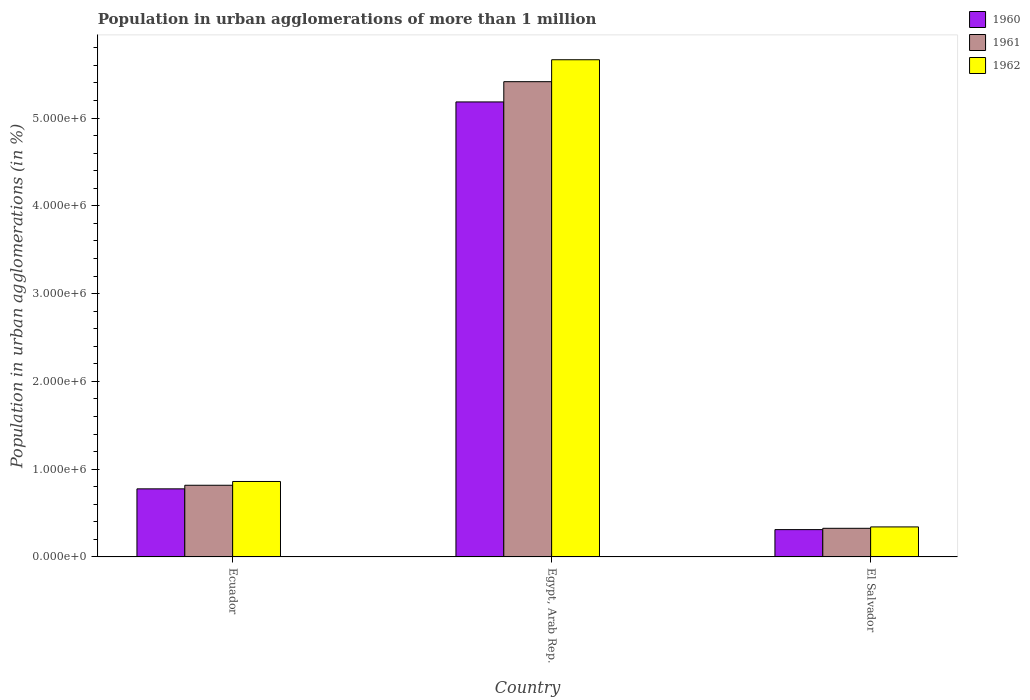How many groups of bars are there?
Keep it short and to the point. 3. Are the number of bars on each tick of the X-axis equal?
Offer a very short reply. Yes. How many bars are there on the 2nd tick from the left?
Offer a very short reply. 3. How many bars are there on the 3rd tick from the right?
Your answer should be very brief. 3. What is the label of the 2nd group of bars from the left?
Make the answer very short. Egypt, Arab Rep. What is the population in urban agglomerations in 1962 in Ecuador?
Your answer should be very brief. 8.60e+05. Across all countries, what is the maximum population in urban agglomerations in 1960?
Provide a succinct answer. 5.18e+06. Across all countries, what is the minimum population in urban agglomerations in 1962?
Provide a succinct answer. 3.42e+05. In which country was the population in urban agglomerations in 1960 maximum?
Offer a very short reply. Egypt, Arab Rep. In which country was the population in urban agglomerations in 1962 minimum?
Offer a terse response. El Salvador. What is the total population in urban agglomerations in 1962 in the graph?
Keep it short and to the point. 6.87e+06. What is the difference between the population in urban agglomerations in 1962 in Egypt, Arab Rep. and that in El Salvador?
Provide a succinct answer. 5.32e+06. What is the difference between the population in urban agglomerations in 1961 in Ecuador and the population in urban agglomerations in 1962 in Egypt, Arab Rep.?
Make the answer very short. -4.85e+06. What is the average population in urban agglomerations in 1962 per country?
Your response must be concise. 2.29e+06. What is the difference between the population in urban agglomerations of/in 1961 and population in urban agglomerations of/in 1960 in Egypt, Arab Rep.?
Give a very brief answer. 2.31e+05. In how many countries, is the population in urban agglomerations in 1961 greater than 3600000 %?
Your answer should be very brief. 1. What is the ratio of the population in urban agglomerations in 1962 in Ecuador to that in Egypt, Arab Rep.?
Provide a succinct answer. 0.15. What is the difference between the highest and the second highest population in urban agglomerations in 1962?
Provide a succinct answer. -5.32e+06. What is the difference between the highest and the lowest population in urban agglomerations in 1960?
Your response must be concise. 4.87e+06. What does the 3rd bar from the right in Egypt, Arab Rep. represents?
Provide a succinct answer. 1960. How many bars are there?
Your answer should be compact. 9. How many countries are there in the graph?
Your response must be concise. 3. What is the difference between two consecutive major ticks on the Y-axis?
Provide a succinct answer. 1.00e+06. Does the graph contain grids?
Offer a very short reply. No. Where does the legend appear in the graph?
Keep it short and to the point. Top right. How many legend labels are there?
Ensure brevity in your answer.  3. What is the title of the graph?
Your response must be concise. Population in urban agglomerations of more than 1 million. Does "1982" appear as one of the legend labels in the graph?
Your answer should be very brief. No. What is the label or title of the Y-axis?
Offer a terse response. Population in urban agglomerations (in %). What is the Population in urban agglomerations (in %) of 1960 in Ecuador?
Keep it short and to the point. 7.76e+05. What is the Population in urban agglomerations (in %) of 1961 in Ecuador?
Your response must be concise. 8.16e+05. What is the Population in urban agglomerations (in %) of 1962 in Ecuador?
Give a very brief answer. 8.60e+05. What is the Population in urban agglomerations (in %) in 1960 in Egypt, Arab Rep.?
Your answer should be compact. 5.18e+06. What is the Population in urban agglomerations (in %) in 1961 in Egypt, Arab Rep.?
Your answer should be compact. 5.41e+06. What is the Population in urban agglomerations (in %) of 1962 in Egypt, Arab Rep.?
Your answer should be very brief. 5.66e+06. What is the Population in urban agglomerations (in %) in 1960 in El Salvador?
Offer a very short reply. 3.11e+05. What is the Population in urban agglomerations (in %) in 1961 in El Salvador?
Offer a terse response. 3.26e+05. What is the Population in urban agglomerations (in %) of 1962 in El Salvador?
Your response must be concise. 3.42e+05. Across all countries, what is the maximum Population in urban agglomerations (in %) of 1960?
Ensure brevity in your answer.  5.18e+06. Across all countries, what is the maximum Population in urban agglomerations (in %) in 1961?
Keep it short and to the point. 5.41e+06. Across all countries, what is the maximum Population in urban agglomerations (in %) in 1962?
Keep it short and to the point. 5.66e+06. Across all countries, what is the minimum Population in urban agglomerations (in %) of 1960?
Your answer should be very brief. 3.11e+05. Across all countries, what is the minimum Population in urban agglomerations (in %) in 1961?
Your response must be concise. 3.26e+05. Across all countries, what is the minimum Population in urban agglomerations (in %) in 1962?
Offer a terse response. 3.42e+05. What is the total Population in urban agglomerations (in %) in 1960 in the graph?
Offer a very short reply. 6.27e+06. What is the total Population in urban agglomerations (in %) of 1961 in the graph?
Ensure brevity in your answer.  6.56e+06. What is the total Population in urban agglomerations (in %) in 1962 in the graph?
Your response must be concise. 6.87e+06. What is the difference between the Population in urban agglomerations (in %) in 1960 in Ecuador and that in Egypt, Arab Rep.?
Your answer should be very brief. -4.41e+06. What is the difference between the Population in urban agglomerations (in %) in 1961 in Ecuador and that in Egypt, Arab Rep.?
Ensure brevity in your answer.  -4.60e+06. What is the difference between the Population in urban agglomerations (in %) of 1962 in Ecuador and that in Egypt, Arab Rep.?
Give a very brief answer. -4.81e+06. What is the difference between the Population in urban agglomerations (in %) of 1960 in Ecuador and that in El Salvador?
Give a very brief answer. 4.64e+05. What is the difference between the Population in urban agglomerations (in %) in 1961 in Ecuador and that in El Salvador?
Offer a very short reply. 4.90e+05. What is the difference between the Population in urban agglomerations (in %) of 1962 in Ecuador and that in El Salvador?
Offer a very short reply. 5.18e+05. What is the difference between the Population in urban agglomerations (in %) of 1960 in Egypt, Arab Rep. and that in El Salvador?
Give a very brief answer. 4.87e+06. What is the difference between the Population in urban agglomerations (in %) in 1961 in Egypt, Arab Rep. and that in El Salvador?
Ensure brevity in your answer.  5.09e+06. What is the difference between the Population in urban agglomerations (in %) of 1962 in Egypt, Arab Rep. and that in El Salvador?
Provide a succinct answer. 5.32e+06. What is the difference between the Population in urban agglomerations (in %) of 1960 in Ecuador and the Population in urban agglomerations (in %) of 1961 in Egypt, Arab Rep.?
Provide a short and direct response. -4.64e+06. What is the difference between the Population in urban agglomerations (in %) in 1960 in Ecuador and the Population in urban agglomerations (in %) in 1962 in Egypt, Arab Rep.?
Your answer should be very brief. -4.89e+06. What is the difference between the Population in urban agglomerations (in %) of 1961 in Ecuador and the Population in urban agglomerations (in %) of 1962 in Egypt, Arab Rep.?
Offer a terse response. -4.85e+06. What is the difference between the Population in urban agglomerations (in %) of 1960 in Ecuador and the Population in urban agglomerations (in %) of 1961 in El Salvador?
Provide a short and direct response. 4.49e+05. What is the difference between the Population in urban agglomerations (in %) in 1960 in Ecuador and the Population in urban agglomerations (in %) in 1962 in El Salvador?
Give a very brief answer. 4.34e+05. What is the difference between the Population in urban agglomerations (in %) of 1961 in Ecuador and the Population in urban agglomerations (in %) of 1962 in El Salvador?
Your answer should be compact. 4.74e+05. What is the difference between the Population in urban agglomerations (in %) in 1960 in Egypt, Arab Rep. and the Population in urban agglomerations (in %) in 1961 in El Salvador?
Offer a terse response. 4.86e+06. What is the difference between the Population in urban agglomerations (in %) in 1960 in Egypt, Arab Rep. and the Population in urban agglomerations (in %) in 1962 in El Salvador?
Your answer should be compact. 4.84e+06. What is the difference between the Population in urban agglomerations (in %) in 1961 in Egypt, Arab Rep. and the Population in urban agglomerations (in %) in 1962 in El Salvador?
Your response must be concise. 5.07e+06. What is the average Population in urban agglomerations (in %) of 1960 per country?
Keep it short and to the point. 2.09e+06. What is the average Population in urban agglomerations (in %) of 1961 per country?
Keep it short and to the point. 2.19e+06. What is the average Population in urban agglomerations (in %) in 1962 per country?
Your answer should be very brief. 2.29e+06. What is the difference between the Population in urban agglomerations (in %) in 1960 and Population in urban agglomerations (in %) in 1961 in Ecuador?
Offer a very short reply. -4.09e+04. What is the difference between the Population in urban agglomerations (in %) in 1960 and Population in urban agglomerations (in %) in 1962 in Ecuador?
Your answer should be very brief. -8.41e+04. What is the difference between the Population in urban agglomerations (in %) in 1961 and Population in urban agglomerations (in %) in 1962 in Ecuador?
Ensure brevity in your answer.  -4.32e+04. What is the difference between the Population in urban agglomerations (in %) in 1960 and Population in urban agglomerations (in %) in 1961 in Egypt, Arab Rep.?
Ensure brevity in your answer.  -2.31e+05. What is the difference between the Population in urban agglomerations (in %) in 1960 and Population in urban agglomerations (in %) in 1962 in Egypt, Arab Rep.?
Provide a short and direct response. -4.81e+05. What is the difference between the Population in urban agglomerations (in %) of 1961 and Population in urban agglomerations (in %) of 1962 in Egypt, Arab Rep.?
Your response must be concise. -2.50e+05. What is the difference between the Population in urban agglomerations (in %) of 1960 and Population in urban agglomerations (in %) of 1961 in El Salvador?
Offer a very short reply. -1.50e+04. What is the difference between the Population in urban agglomerations (in %) in 1960 and Population in urban agglomerations (in %) in 1962 in El Salvador?
Your answer should be very brief. -3.08e+04. What is the difference between the Population in urban agglomerations (in %) in 1961 and Population in urban agglomerations (in %) in 1962 in El Salvador?
Your response must be concise. -1.58e+04. What is the ratio of the Population in urban agglomerations (in %) of 1960 in Ecuador to that in Egypt, Arab Rep.?
Your answer should be compact. 0.15. What is the ratio of the Population in urban agglomerations (in %) in 1961 in Ecuador to that in Egypt, Arab Rep.?
Ensure brevity in your answer.  0.15. What is the ratio of the Population in urban agglomerations (in %) of 1962 in Ecuador to that in Egypt, Arab Rep.?
Ensure brevity in your answer.  0.15. What is the ratio of the Population in urban agglomerations (in %) in 1960 in Ecuador to that in El Salvador?
Give a very brief answer. 2.49. What is the ratio of the Population in urban agglomerations (in %) in 1961 in Ecuador to that in El Salvador?
Your answer should be very brief. 2.5. What is the ratio of the Population in urban agglomerations (in %) of 1962 in Ecuador to that in El Salvador?
Your answer should be compact. 2.51. What is the ratio of the Population in urban agglomerations (in %) in 1960 in Egypt, Arab Rep. to that in El Salvador?
Your response must be concise. 16.66. What is the ratio of the Population in urban agglomerations (in %) in 1961 in Egypt, Arab Rep. to that in El Salvador?
Your answer should be compact. 16.6. What is the ratio of the Population in urban agglomerations (in %) in 1962 in Egypt, Arab Rep. to that in El Salvador?
Offer a terse response. 16.56. What is the difference between the highest and the second highest Population in urban agglomerations (in %) of 1960?
Make the answer very short. 4.41e+06. What is the difference between the highest and the second highest Population in urban agglomerations (in %) of 1961?
Make the answer very short. 4.60e+06. What is the difference between the highest and the second highest Population in urban agglomerations (in %) of 1962?
Make the answer very short. 4.81e+06. What is the difference between the highest and the lowest Population in urban agglomerations (in %) in 1960?
Provide a succinct answer. 4.87e+06. What is the difference between the highest and the lowest Population in urban agglomerations (in %) in 1961?
Make the answer very short. 5.09e+06. What is the difference between the highest and the lowest Population in urban agglomerations (in %) in 1962?
Provide a succinct answer. 5.32e+06. 